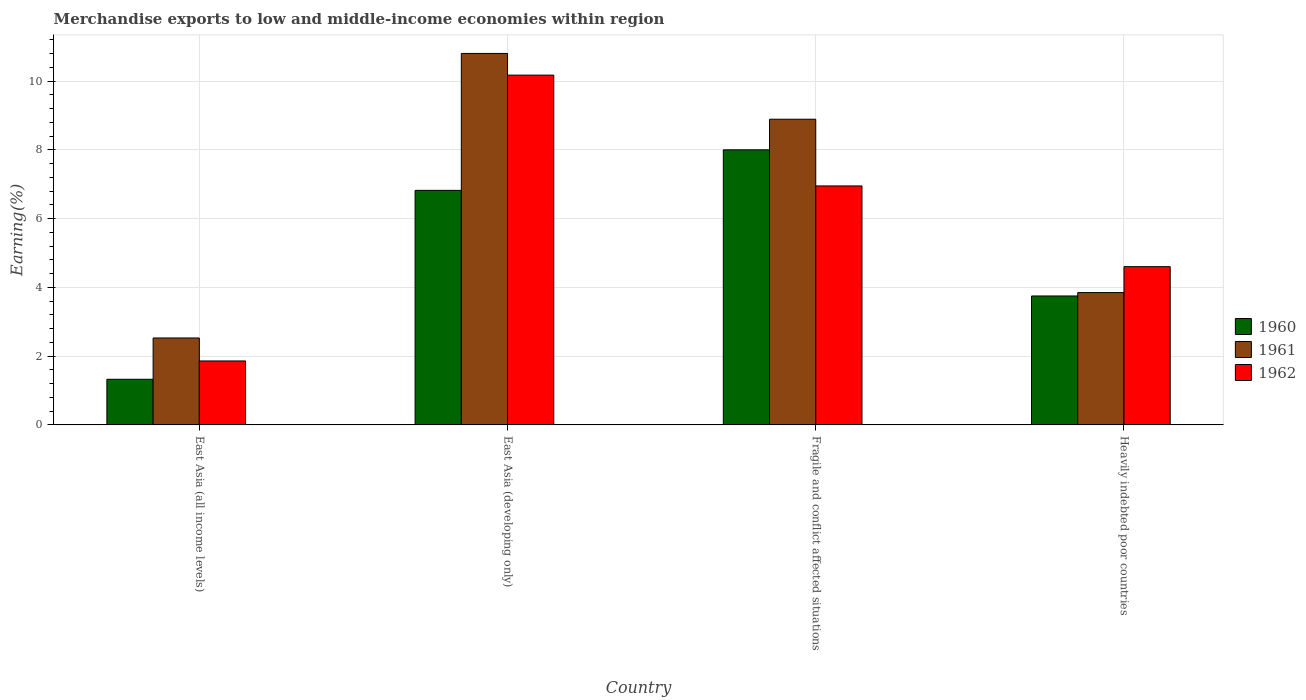How many different coloured bars are there?
Give a very brief answer. 3. How many groups of bars are there?
Offer a terse response. 4. Are the number of bars per tick equal to the number of legend labels?
Offer a very short reply. Yes. Are the number of bars on each tick of the X-axis equal?
Offer a terse response. Yes. How many bars are there on the 4th tick from the left?
Give a very brief answer. 3. How many bars are there on the 3rd tick from the right?
Provide a short and direct response. 3. What is the label of the 3rd group of bars from the left?
Ensure brevity in your answer.  Fragile and conflict affected situations. In how many cases, is the number of bars for a given country not equal to the number of legend labels?
Your response must be concise. 0. What is the percentage of amount earned from merchandise exports in 1961 in East Asia (all income levels)?
Offer a very short reply. 2.53. Across all countries, what is the maximum percentage of amount earned from merchandise exports in 1962?
Ensure brevity in your answer.  10.17. Across all countries, what is the minimum percentage of amount earned from merchandise exports in 1962?
Provide a short and direct response. 1.86. In which country was the percentage of amount earned from merchandise exports in 1962 maximum?
Your answer should be compact. East Asia (developing only). In which country was the percentage of amount earned from merchandise exports in 1961 minimum?
Your response must be concise. East Asia (all income levels). What is the total percentage of amount earned from merchandise exports in 1961 in the graph?
Your answer should be compact. 26.07. What is the difference between the percentage of amount earned from merchandise exports in 1962 in East Asia (all income levels) and that in Fragile and conflict affected situations?
Your answer should be compact. -5.09. What is the difference between the percentage of amount earned from merchandise exports in 1962 in East Asia (developing only) and the percentage of amount earned from merchandise exports in 1961 in Fragile and conflict affected situations?
Offer a terse response. 1.28. What is the average percentage of amount earned from merchandise exports in 1961 per country?
Provide a succinct answer. 6.52. What is the difference between the percentage of amount earned from merchandise exports of/in 1961 and percentage of amount earned from merchandise exports of/in 1962 in East Asia (all income levels)?
Give a very brief answer. 0.67. What is the ratio of the percentage of amount earned from merchandise exports in 1961 in East Asia (all income levels) to that in Fragile and conflict affected situations?
Offer a terse response. 0.28. Is the difference between the percentage of amount earned from merchandise exports in 1961 in East Asia (all income levels) and Fragile and conflict affected situations greater than the difference between the percentage of amount earned from merchandise exports in 1962 in East Asia (all income levels) and Fragile and conflict affected situations?
Provide a succinct answer. No. What is the difference between the highest and the second highest percentage of amount earned from merchandise exports in 1960?
Keep it short and to the point. 4.25. What is the difference between the highest and the lowest percentage of amount earned from merchandise exports in 1960?
Your answer should be very brief. 6.67. In how many countries, is the percentage of amount earned from merchandise exports in 1960 greater than the average percentage of amount earned from merchandise exports in 1960 taken over all countries?
Provide a succinct answer. 2. What does the 1st bar from the left in East Asia (developing only) represents?
Make the answer very short. 1960. Is it the case that in every country, the sum of the percentage of amount earned from merchandise exports in 1962 and percentage of amount earned from merchandise exports in 1960 is greater than the percentage of amount earned from merchandise exports in 1961?
Provide a short and direct response. Yes. How many bars are there?
Your answer should be compact. 12. What is the difference between two consecutive major ticks on the Y-axis?
Provide a succinct answer. 2. Are the values on the major ticks of Y-axis written in scientific E-notation?
Your answer should be very brief. No. How many legend labels are there?
Provide a succinct answer. 3. How are the legend labels stacked?
Your answer should be compact. Vertical. What is the title of the graph?
Make the answer very short. Merchandise exports to low and middle-income economies within region. What is the label or title of the X-axis?
Keep it short and to the point. Country. What is the label or title of the Y-axis?
Your answer should be compact. Earning(%). What is the Earning(%) in 1960 in East Asia (all income levels)?
Make the answer very short. 1.33. What is the Earning(%) of 1961 in East Asia (all income levels)?
Provide a short and direct response. 2.53. What is the Earning(%) in 1962 in East Asia (all income levels)?
Offer a very short reply. 1.86. What is the Earning(%) in 1960 in East Asia (developing only)?
Keep it short and to the point. 6.82. What is the Earning(%) in 1961 in East Asia (developing only)?
Ensure brevity in your answer.  10.8. What is the Earning(%) in 1962 in East Asia (developing only)?
Keep it short and to the point. 10.17. What is the Earning(%) in 1960 in Fragile and conflict affected situations?
Keep it short and to the point. 8. What is the Earning(%) in 1961 in Fragile and conflict affected situations?
Provide a succinct answer. 8.89. What is the Earning(%) of 1962 in Fragile and conflict affected situations?
Make the answer very short. 6.95. What is the Earning(%) of 1960 in Heavily indebted poor countries?
Provide a short and direct response. 3.75. What is the Earning(%) in 1961 in Heavily indebted poor countries?
Offer a terse response. 3.85. What is the Earning(%) of 1962 in Heavily indebted poor countries?
Keep it short and to the point. 4.6. Across all countries, what is the maximum Earning(%) of 1960?
Give a very brief answer. 8. Across all countries, what is the maximum Earning(%) in 1961?
Ensure brevity in your answer.  10.8. Across all countries, what is the maximum Earning(%) of 1962?
Ensure brevity in your answer.  10.17. Across all countries, what is the minimum Earning(%) of 1960?
Your answer should be compact. 1.33. Across all countries, what is the minimum Earning(%) in 1961?
Provide a succinct answer. 2.53. Across all countries, what is the minimum Earning(%) in 1962?
Make the answer very short. 1.86. What is the total Earning(%) of 1960 in the graph?
Provide a short and direct response. 19.9. What is the total Earning(%) of 1961 in the graph?
Give a very brief answer. 26.07. What is the total Earning(%) in 1962 in the graph?
Your answer should be compact. 23.59. What is the difference between the Earning(%) in 1960 in East Asia (all income levels) and that in East Asia (developing only)?
Your answer should be compact. -5.49. What is the difference between the Earning(%) of 1961 in East Asia (all income levels) and that in East Asia (developing only)?
Provide a short and direct response. -8.28. What is the difference between the Earning(%) in 1962 in East Asia (all income levels) and that in East Asia (developing only)?
Make the answer very short. -8.31. What is the difference between the Earning(%) of 1960 in East Asia (all income levels) and that in Fragile and conflict affected situations?
Provide a succinct answer. -6.67. What is the difference between the Earning(%) in 1961 in East Asia (all income levels) and that in Fragile and conflict affected situations?
Make the answer very short. -6.36. What is the difference between the Earning(%) in 1962 in East Asia (all income levels) and that in Fragile and conflict affected situations?
Offer a terse response. -5.09. What is the difference between the Earning(%) in 1960 in East Asia (all income levels) and that in Heavily indebted poor countries?
Your answer should be very brief. -2.42. What is the difference between the Earning(%) of 1961 in East Asia (all income levels) and that in Heavily indebted poor countries?
Provide a short and direct response. -1.32. What is the difference between the Earning(%) in 1962 in East Asia (all income levels) and that in Heavily indebted poor countries?
Keep it short and to the point. -2.74. What is the difference between the Earning(%) of 1960 in East Asia (developing only) and that in Fragile and conflict affected situations?
Your answer should be compact. -1.18. What is the difference between the Earning(%) in 1961 in East Asia (developing only) and that in Fragile and conflict affected situations?
Give a very brief answer. 1.91. What is the difference between the Earning(%) of 1962 in East Asia (developing only) and that in Fragile and conflict affected situations?
Your answer should be very brief. 3.22. What is the difference between the Earning(%) of 1960 in East Asia (developing only) and that in Heavily indebted poor countries?
Your response must be concise. 3.07. What is the difference between the Earning(%) of 1961 in East Asia (developing only) and that in Heavily indebted poor countries?
Offer a terse response. 6.96. What is the difference between the Earning(%) of 1962 in East Asia (developing only) and that in Heavily indebted poor countries?
Your response must be concise. 5.57. What is the difference between the Earning(%) of 1960 in Fragile and conflict affected situations and that in Heavily indebted poor countries?
Your answer should be very brief. 4.25. What is the difference between the Earning(%) in 1961 in Fragile and conflict affected situations and that in Heavily indebted poor countries?
Your response must be concise. 5.04. What is the difference between the Earning(%) of 1962 in Fragile and conflict affected situations and that in Heavily indebted poor countries?
Provide a short and direct response. 2.35. What is the difference between the Earning(%) in 1960 in East Asia (all income levels) and the Earning(%) in 1961 in East Asia (developing only)?
Provide a succinct answer. -9.48. What is the difference between the Earning(%) in 1960 in East Asia (all income levels) and the Earning(%) in 1962 in East Asia (developing only)?
Ensure brevity in your answer.  -8.85. What is the difference between the Earning(%) in 1961 in East Asia (all income levels) and the Earning(%) in 1962 in East Asia (developing only)?
Keep it short and to the point. -7.65. What is the difference between the Earning(%) of 1960 in East Asia (all income levels) and the Earning(%) of 1961 in Fragile and conflict affected situations?
Your answer should be very brief. -7.56. What is the difference between the Earning(%) of 1960 in East Asia (all income levels) and the Earning(%) of 1962 in Fragile and conflict affected situations?
Your answer should be compact. -5.62. What is the difference between the Earning(%) in 1961 in East Asia (all income levels) and the Earning(%) in 1962 in Fragile and conflict affected situations?
Make the answer very short. -4.42. What is the difference between the Earning(%) in 1960 in East Asia (all income levels) and the Earning(%) in 1961 in Heavily indebted poor countries?
Your answer should be compact. -2.52. What is the difference between the Earning(%) in 1960 in East Asia (all income levels) and the Earning(%) in 1962 in Heavily indebted poor countries?
Provide a short and direct response. -3.28. What is the difference between the Earning(%) of 1961 in East Asia (all income levels) and the Earning(%) of 1962 in Heavily indebted poor countries?
Ensure brevity in your answer.  -2.07. What is the difference between the Earning(%) of 1960 in East Asia (developing only) and the Earning(%) of 1961 in Fragile and conflict affected situations?
Your answer should be compact. -2.07. What is the difference between the Earning(%) in 1960 in East Asia (developing only) and the Earning(%) in 1962 in Fragile and conflict affected situations?
Provide a short and direct response. -0.13. What is the difference between the Earning(%) of 1961 in East Asia (developing only) and the Earning(%) of 1962 in Fragile and conflict affected situations?
Make the answer very short. 3.85. What is the difference between the Earning(%) in 1960 in East Asia (developing only) and the Earning(%) in 1961 in Heavily indebted poor countries?
Make the answer very short. 2.97. What is the difference between the Earning(%) in 1960 in East Asia (developing only) and the Earning(%) in 1962 in Heavily indebted poor countries?
Your answer should be very brief. 2.22. What is the difference between the Earning(%) in 1961 in East Asia (developing only) and the Earning(%) in 1962 in Heavily indebted poor countries?
Offer a terse response. 6.2. What is the difference between the Earning(%) in 1960 in Fragile and conflict affected situations and the Earning(%) in 1961 in Heavily indebted poor countries?
Your answer should be very brief. 4.15. What is the difference between the Earning(%) of 1960 in Fragile and conflict affected situations and the Earning(%) of 1962 in Heavily indebted poor countries?
Offer a very short reply. 3.4. What is the difference between the Earning(%) of 1961 in Fragile and conflict affected situations and the Earning(%) of 1962 in Heavily indebted poor countries?
Keep it short and to the point. 4.29. What is the average Earning(%) of 1960 per country?
Offer a terse response. 4.97. What is the average Earning(%) in 1961 per country?
Your answer should be very brief. 6.52. What is the average Earning(%) of 1962 per country?
Your answer should be compact. 5.9. What is the difference between the Earning(%) of 1960 and Earning(%) of 1961 in East Asia (all income levels)?
Your answer should be compact. -1.2. What is the difference between the Earning(%) of 1960 and Earning(%) of 1962 in East Asia (all income levels)?
Give a very brief answer. -0.53. What is the difference between the Earning(%) in 1961 and Earning(%) in 1962 in East Asia (all income levels)?
Give a very brief answer. 0.67. What is the difference between the Earning(%) in 1960 and Earning(%) in 1961 in East Asia (developing only)?
Your answer should be compact. -3.98. What is the difference between the Earning(%) in 1960 and Earning(%) in 1962 in East Asia (developing only)?
Provide a short and direct response. -3.35. What is the difference between the Earning(%) of 1961 and Earning(%) of 1962 in East Asia (developing only)?
Your answer should be compact. 0.63. What is the difference between the Earning(%) of 1960 and Earning(%) of 1961 in Fragile and conflict affected situations?
Provide a succinct answer. -0.89. What is the difference between the Earning(%) in 1960 and Earning(%) in 1962 in Fragile and conflict affected situations?
Your answer should be very brief. 1.05. What is the difference between the Earning(%) in 1961 and Earning(%) in 1962 in Fragile and conflict affected situations?
Offer a terse response. 1.94. What is the difference between the Earning(%) in 1960 and Earning(%) in 1961 in Heavily indebted poor countries?
Offer a very short reply. -0.1. What is the difference between the Earning(%) in 1960 and Earning(%) in 1962 in Heavily indebted poor countries?
Make the answer very short. -0.85. What is the difference between the Earning(%) of 1961 and Earning(%) of 1962 in Heavily indebted poor countries?
Keep it short and to the point. -0.75. What is the ratio of the Earning(%) in 1960 in East Asia (all income levels) to that in East Asia (developing only)?
Offer a very short reply. 0.19. What is the ratio of the Earning(%) of 1961 in East Asia (all income levels) to that in East Asia (developing only)?
Offer a very short reply. 0.23. What is the ratio of the Earning(%) of 1962 in East Asia (all income levels) to that in East Asia (developing only)?
Provide a short and direct response. 0.18. What is the ratio of the Earning(%) in 1960 in East Asia (all income levels) to that in Fragile and conflict affected situations?
Your answer should be very brief. 0.17. What is the ratio of the Earning(%) in 1961 in East Asia (all income levels) to that in Fragile and conflict affected situations?
Your answer should be very brief. 0.28. What is the ratio of the Earning(%) of 1962 in East Asia (all income levels) to that in Fragile and conflict affected situations?
Provide a succinct answer. 0.27. What is the ratio of the Earning(%) in 1960 in East Asia (all income levels) to that in Heavily indebted poor countries?
Your answer should be very brief. 0.35. What is the ratio of the Earning(%) in 1961 in East Asia (all income levels) to that in Heavily indebted poor countries?
Your answer should be very brief. 0.66. What is the ratio of the Earning(%) in 1962 in East Asia (all income levels) to that in Heavily indebted poor countries?
Give a very brief answer. 0.4. What is the ratio of the Earning(%) in 1960 in East Asia (developing only) to that in Fragile and conflict affected situations?
Offer a very short reply. 0.85. What is the ratio of the Earning(%) of 1961 in East Asia (developing only) to that in Fragile and conflict affected situations?
Offer a terse response. 1.22. What is the ratio of the Earning(%) of 1962 in East Asia (developing only) to that in Fragile and conflict affected situations?
Give a very brief answer. 1.46. What is the ratio of the Earning(%) in 1960 in East Asia (developing only) to that in Heavily indebted poor countries?
Provide a succinct answer. 1.82. What is the ratio of the Earning(%) in 1961 in East Asia (developing only) to that in Heavily indebted poor countries?
Provide a short and direct response. 2.81. What is the ratio of the Earning(%) of 1962 in East Asia (developing only) to that in Heavily indebted poor countries?
Your answer should be very brief. 2.21. What is the ratio of the Earning(%) in 1960 in Fragile and conflict affected situations to that in Heavily indebted poor countries?
Your answer should be very brief. 2.13. What is the ratio of the Earning(%) in 1961 in Fragile and conflict affected situations to that in Heavily indebted poor countries?
Your response must be concise. 2.31. What is the ratio of the Earning(%) of 1962 in Fragile and conflict affected situations to that in Heavily indebted poor countries?
Offer a terse response. 1.51. What is the difference between the highest and the second highest Earning(%) in 1960?
Provide a short and direct response. 1.18. What is the difference between the highest and the second highest Earning(%) of 1961?
Offer a very short reply. 1.91. What is the difference between the highest and the second highest Earning(%) of 1962?
Offer a terse response. 3.22. What is the difference between the highest and the lowest Earning(%) of 1960?
Make the answer very short. 6.67. What is the difference between the highest and the lowest Earning(%) in 1961?
Your response must be concise. 8.28. What is the difference between the highest and the lowest Earning(%) of 1962?
Your answer should be compact. 8.31. 